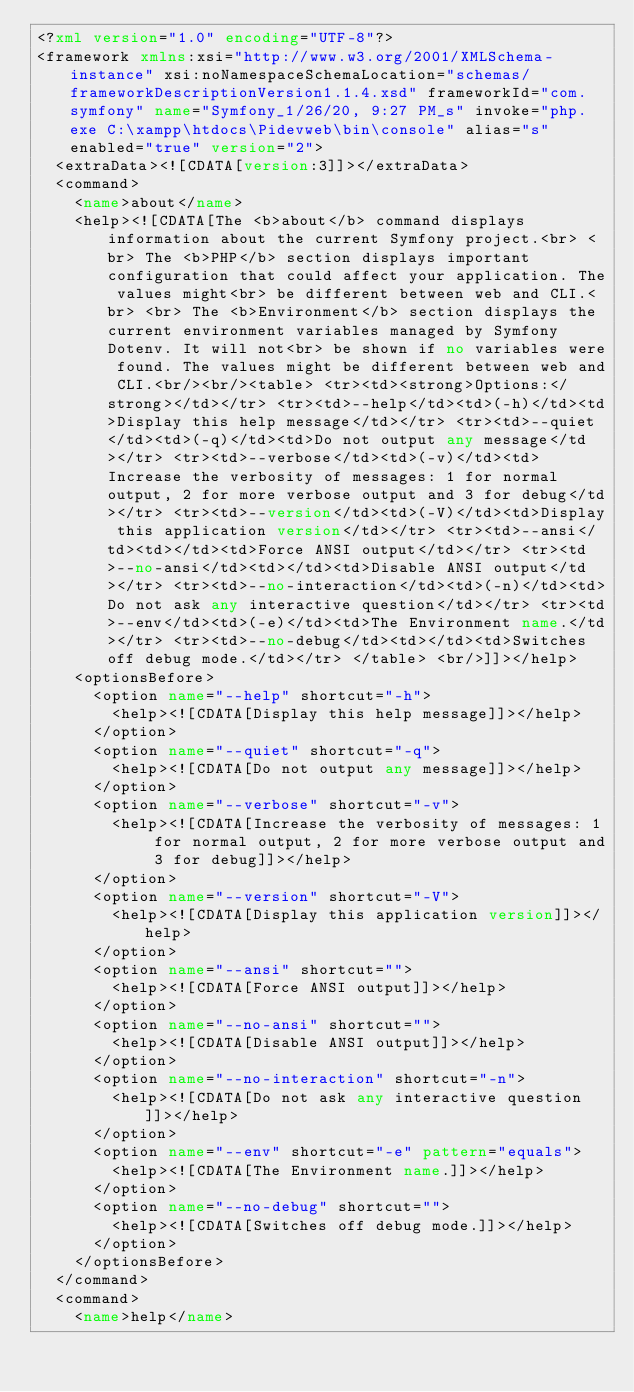<code> <loc_0><loc_0><loc_500><loc_500><_XML_><?xml version="1.0" encoding="UTF-8"?>
<framework xmlns:xsi="http://www.w3.org/2001/XMLSchema-instance" xsi:noNamespaceSchemaLocation="schemas/frameworkDescriptionVersion1.1.4.xsd" frameworkId="com.symfony" name="Symfony_1/26/20, 9:27 PM_s" invoke="php.exe C:\xampp\htdocs\Pidevweb\bin\console" alias="s" enabled="true" version="2">
  <extraData><![CDATA[version:3]]></extraData>
  <command>
    <name>about</name>
    <help><![CDATA[The <b>about</b> command displays information about the current Symfony project.<br> <br> The <b>PHP</b> section displays important configuration that could affect your application. The values might<br> be different between web and CLI.<br> <br> The <b>Environment</b> section displays the current environment variables managed by Symfony Dotenv. It will not<br> be shown if no variables were found. The values might be different between web and CLI.<br/><br/><table> <tr><td><strong>Options:</strong></td></tr> <tr><td>--help</td><td>(-h)</td><td>Display this help message</td></tr> <tr><td>--quiet</td><td>(-q)</td><td>Do not output any message</td></tr> <tr><td>--verbose</td><td>(-v)</td><td>Increase the verbosity of messages: 1 for normal output, 2 for more verbose output and 3 for debug</td></tr> <tr><td>--version</td><td>(-V)</td><td>Display this application version</td></tr> <tr><td>--ansi</td><td></td><td>Force ANSI output</td></tr> <tr><td>--no-ansi</td><td></td><td>Disable ANSI output</td></tr> <tr><td>--no-interaction</td><td>(-n)</td><td>Do not ask any interactive question</td></tr> <tr><td>--env</td><td>(-e)</td><td>The Environment name.</td></tr> <tr><td>--no-debug</td><td></td><td>Switches off debug mode.</td></tr> </table> <br/>]]></help>
    <optionsBefore>
      <option name="--help" shortcut="-h">
        <help><![CDATA[Display this help message]]></help>
      </option>
      <option name="--quiet" shortcut="-q">
        <help><![CDATA[Do not output any message]]></help>
      </option>
      <option name="--verbose" shortcut="-v">
        <help><![CDATA[Increase the verbosity of messages: 1 for normal output, 2 for more verbose output and 3 for debug]]></help>
      </option>
      <option name="--version" shortcut="-V">
        <help><![CDATA[Display this application version]]></help>
      </option>
      <option name="--ansi" shortcut="">
        <help><![CDATA[Force ANSI output]]></help>
      </option>
      <option name="--no-ansi" shortcut="">
        <help><![CDATA[Disable ANSI output]]></help>
      </option>
      <option name="--no-interaction" shortcut="-n">
        <help><![CDATA[Do not ask any interactive question]]></help>
      </option>
      <option name="--env" shortcut="-e" pattern="equals">
        <help><![CDATA[The Environment name.]]></help>
      </option>
      <option name="--no-debug" shortcut="">
        <help><![CDATA[Switches off debug mode.]]></help>
      </option>
    </optionsBefore>
  </command>
  <command>
    <name>help</name></code> 